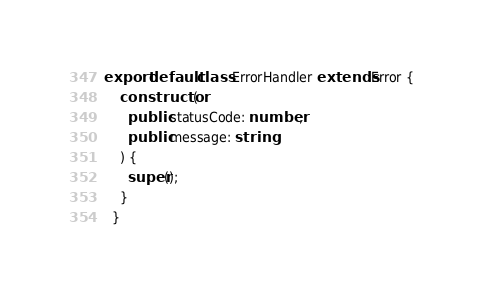Convert code to text. <code><loc_0><loc_0><loc_500><loc_500><_TypeScript_>export default class ErrorHandler extends Error {
    constructor(
      public statusCode: number,
      public message: string
    ) {
      super();
    }
  }</code> 